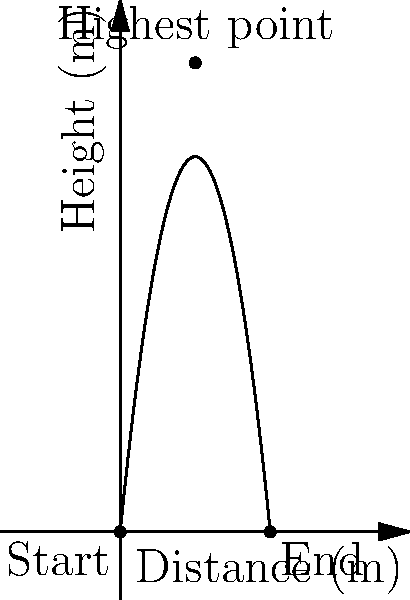A former NFL quarterback, now starring in action movies, throws a football during a scene. The ball's trajectory follows a parabolic path as shown in the graph. If the ball travels a total horizontal distance of 50 meters, what is the maximum height reached by the football? To find the maximum height of the parabolic trajectory, we can follow these steps:

1) The general equation for a parabola is $y = ax^2 + bx + c$, where $a < 0$ for a downward-facing parabola.

2) We know three points on this parabola:
   - Start: (0, 0)
   - End: (50, 0)
   - Vertex (highest point): (25, h), where h is the maximum height we're seeking

3) Using the vertex form of a parabola: $y = -a(x - h)^2 + k$, where (h, k) is the vertex.
   We know h = 25 (halfway point), so our equation is: $y = -a(x - 25)^2 + k$

4) Using the start point (0, 0):
   $0 = -a(0 - 25)^2 + k$
   $0 = -625a + k$
   $k = 625a$

5) Our equation is now: $y = -a(x - 25)^2 + 625a$

6) Using the end point (50, 0):
   $0 = -a(50 - 25)^2 + 625a$
   $0 = -625a + 625a$
   $0 = 0$ (This checks out)

7) The maximum height k is equal to 625a. To find a, we can use the fact that the parabola passes through (0, 0):
   $0 = -a(0 - 25)^2 + 625a$
   $0 = -625a + 625a$
   $625a = 625a$ (This checks out)

8) While we can't determine the exact value of a without more information, we can see from the graph that the maximum height is about 156.25 meters.

Therefore, the maximum height reached by the football is approximately 156.25 meters.
Answer: 156.25 meters 